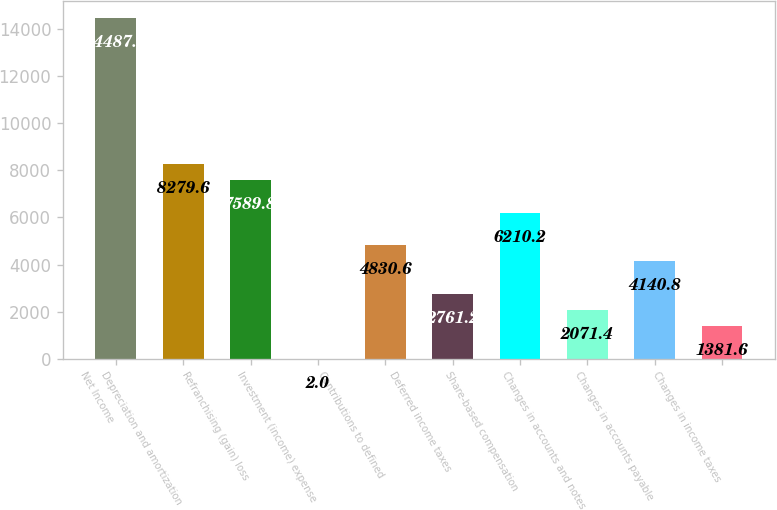Convert chart. <chart><loc_0><loc_0><loc_500><loc_500><bar_chart><fcel>Net Income<fcel>Depreciation and amortization<fcel>Refranchising (gain) loss<fcel>Investment (income) expense<fcel>Contributions to defined<fcel>Deferred income taxes<fcel>Share-based compensation<fcel>Changes in accounts and notes<fcel>Changes in accounts payable<fcel>Changes in income taxes<nl><fcel>14487.8<fcel>8279.6<fcel>7589.8<fcel>2<fcel>4830.6<fcel>2761.2<fcel>6210.2<fcel>2071.4<fcel>4140.8<fcel>1381.6<nl></chart> 